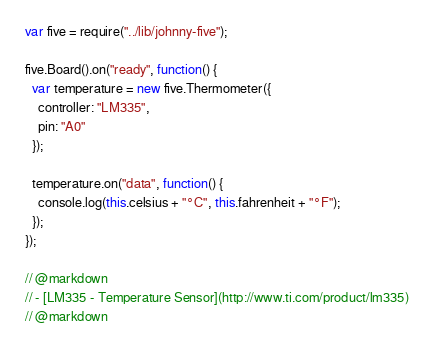Convert code to text. <code><loc_0><loc_0><loc_500><loc_500><_JavaScript_>var five = require("../lib/johnny-five");

five.Board().on("ready", function() {
  var temperature = new five.Thermometer({
    controller: "LM335",
    pin: "A0"
  });

  temperature.on("data", function() {
    console.log(this.celsius + "°C", this.fahrenheit + "°F");
  });
});

// @markdown
// - [LM335 - Temperature Sensor](http://www.ti.com/product/lm335)
// @markdown
</code> 